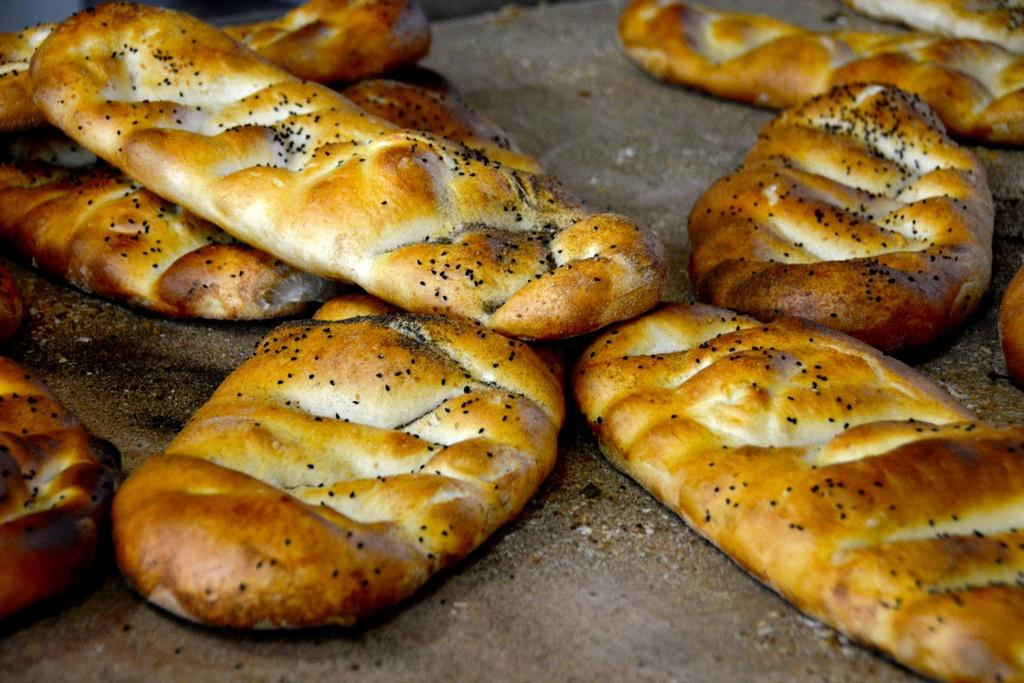What type of food can be seen in the image? There are breads in the image. What design can be seen on the bread in the image? There is no specific design mentioned on the bread in the image. 